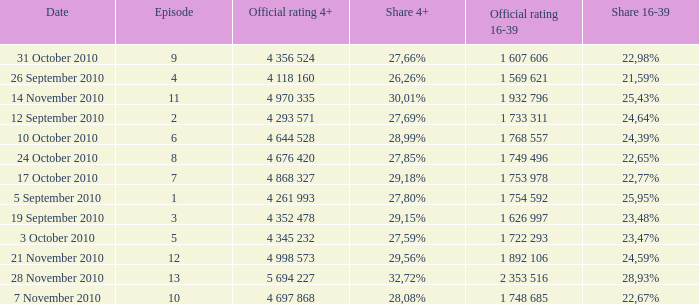What is the official 4+ rating of the episode with a 16-39 share of 24,59%? 4 998 573. 